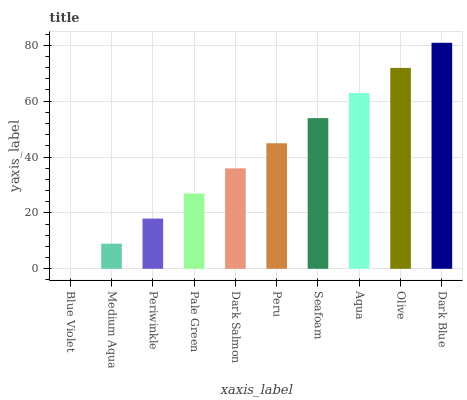Is Blue Violet the minimum?
Answer yes or no. Yes. Is Dark Blue the maximum?
Answer yes or no. Yes. Is Medium Aqua the minimum?
Answer yes or no. No. Is Medium Aqua the maximum?
Answer yes or no. No. Is Medium Aqua greater than Blue Violet?
Answer yes or no. Yes. Is Blue Violet less than Medium Aqua?
Answer yes or no. Yes. Is Blue Violet greater than Medium Aqua?
Answer yes or no. No. Is Medium Aqua less than Blue Violet?
Answer yes or no. No. Is Peru the high median?
Answer yes or no. Yes. Is Dark Salmon the low median?
Answer yes or no. Yes. Is Aqua the high median?
Answer yes or no. No. Is Periwinkle the low median?
Answer yes or no. No. 